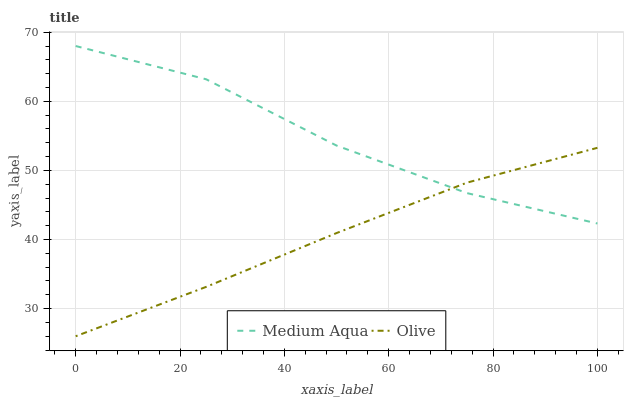Does Olive have the minimum area under the curve?
Answer yes or no. Yes. Does Medium Aqua have the maximum area under the curve?
Answer yes or no. Yes. Does Medium Aqua have the minimum area under the curve?
Answer yes or no. No. Is Olive the smoothest?
Answer yes or no. Yes. Is Medium Aqua the roughest?
Answer yes or no. Yes. Is Medium Aqua the smoothest?
Answer yes or no. No. Does Olive have the lowest value?
Answer yes or no. Yes. Does Medium Aqua have the lowest value?
Answer yes or no. No. Does Medium Aqua have the highest value?
Answer yes or no. Yes. Does Medium Aqua intersect Olive?
Answer yes or no. Yes. Is Medium Aqua less than Olive?
Answer yes or no. No. Is Medium Aqua greater than Olive?
Answer yes or no. No. 